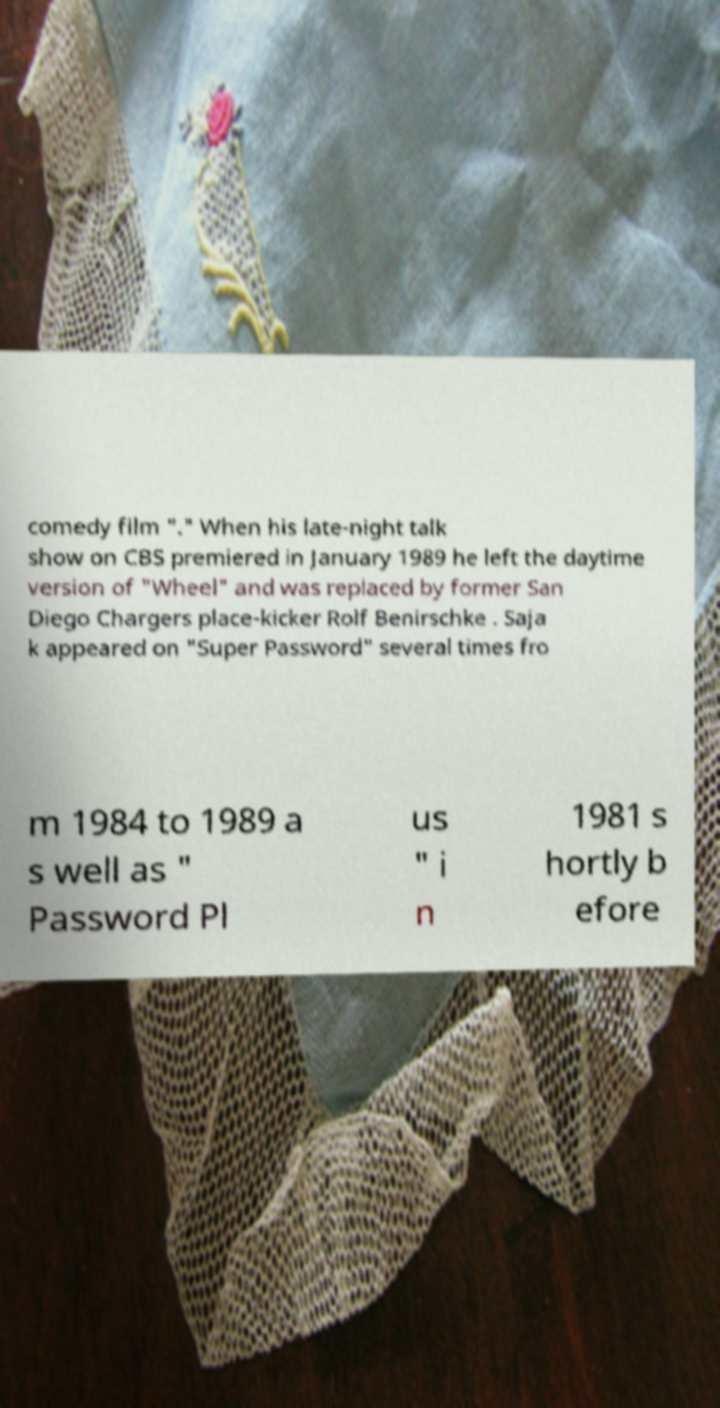Can you accurately transcribe the text from the provided image for me? comedy film "." When his late-night talk show on CBS premiered in January 1989 he left the daytime version of "Wheel" and was replaced by former San Diego Chargers place-kicker Rolf Benirschke . Saja k appeared on "Super Password" several times fro m 1984 to 1989 a s well as " Password Pl us " i n 1981 s hortly b efore 